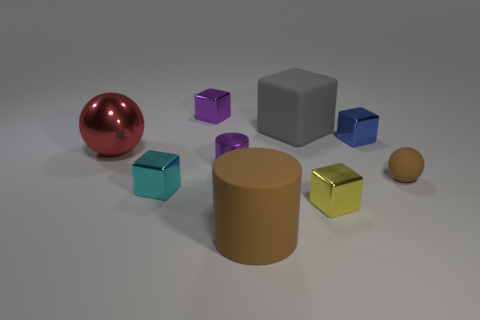Subtract all rubber blocks. How many blocks are left? 4 Subtract all gray blocks. How many blocks are left? 4 Subtract all spheres. How many objects are left? 7 Subtract all brown balls. Subtract all gray cylinders. How many balls are left? 1 Subtract all brown cubes. How many purple cylinders are left? 1 Subtract all red rubber things. Subtract all gray matte cubes. How many objects are left? 8 Add 7 big rubber things. How many big rubber things are left? 9 Add 2 cylinders. How many cylinders exist? 4 Subtract 0 yellow spheres. How many objects are left? 9 Subtract 2 spheres. How many spheres are left? 0 